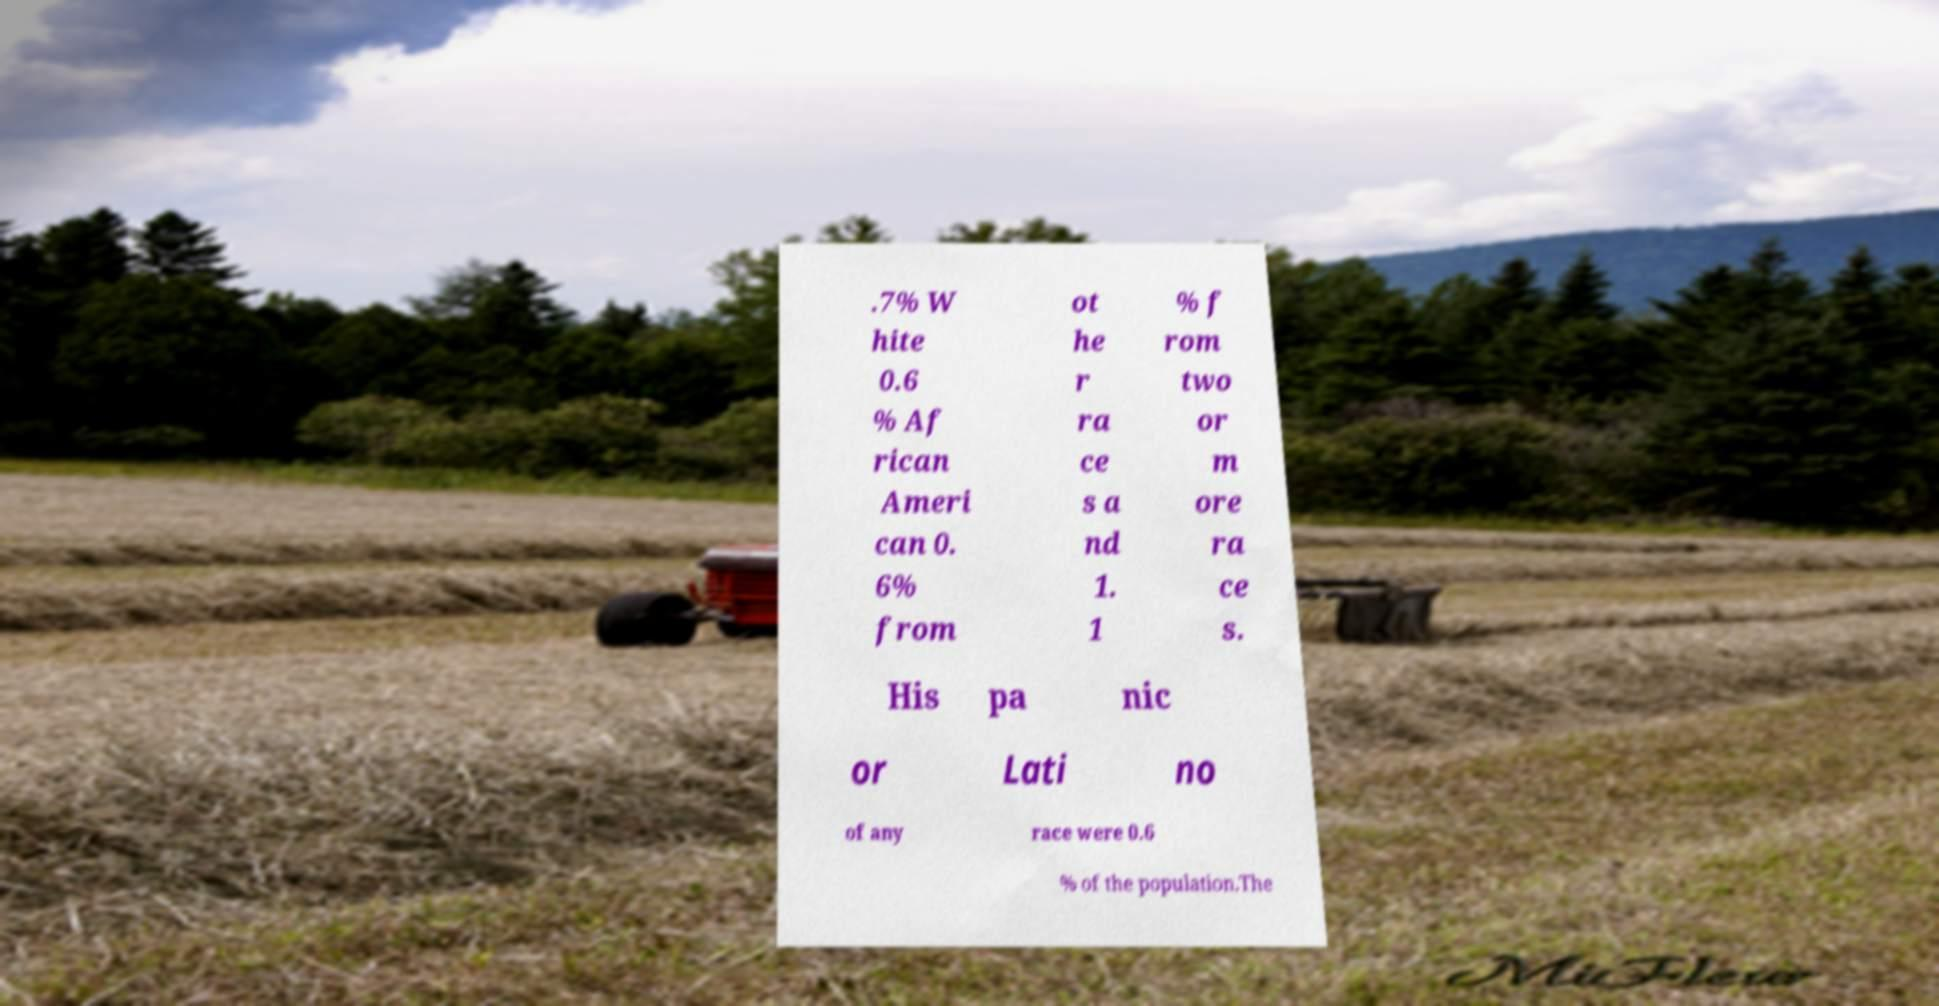Could you assist in decoding the text presented in this image and type it out clearly? .7% W hite 0.6 % Af rican Ameri can 0. 6% from ot he r ra ce s a nd 1. 1 % f rom two or m ore ra ce s. His pa nic or Lati no of any race were 0.6 % of the population.The 